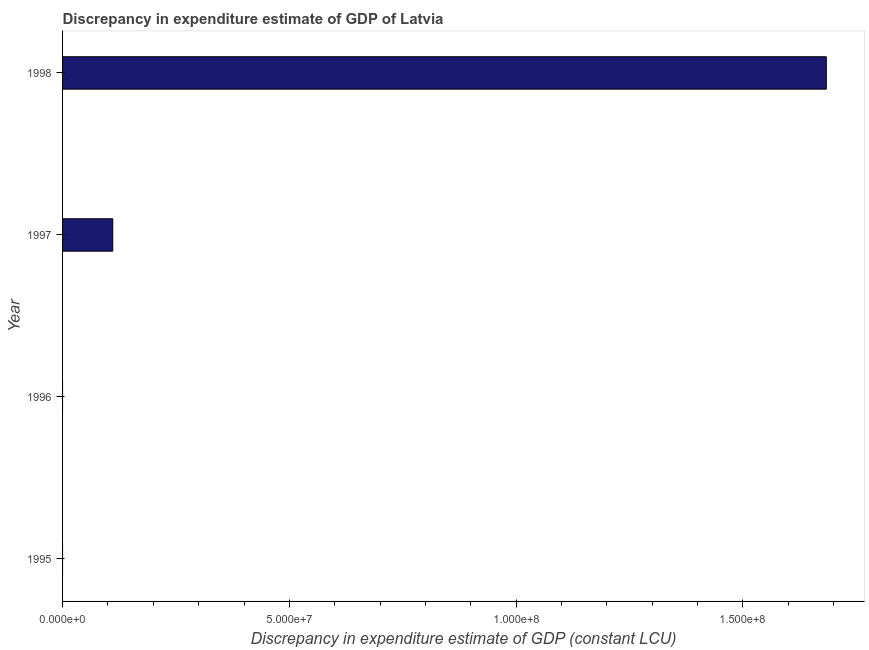Does the graph contain any zero values?
Offer a very short reply. Yes. What is the title of the graph?
Provide a short and direct response. Discrepancy in expenditure estimate of GDP of Latvia. What is the label or title of the X-axis?
Keep it short and to the point. Discrepancy in expenditure estimate of GDP (constant LCU). What is the discrepancy in expenditure estimate of gdp in 1997?
Your response must be concise. 1.11e+07. Across all years, what is the maximum discrepancy in expenditure estimate of gdp?
Give a very brief answer. 1.68e+08. What is the sum of the discrepancy in expenditure estimate of gdp?
Offer a terse response. 1.79e+08. What is the average discrepancy in expenditure estimate of gdp per year?
Keep it short and to the point. 4.49e+07. What is the median discrepancy in expenditure estimate of gdp?
Offer a terse response. 5.53e+06. In how many years, is the discrepancy in expenditure estimate of gdp greater than 80000000 LCU?
Make the answer very short. 1. What is the ratio of the discrepancy in expenditure estimate of gdp in 1997 to that in 1998?
Your response must be concise. 0.07. Is the discrepancy in expenditure estimate of gdp in 1997 less than that in 1998?
Your answer should be compact. Yes. Is the difference between the discrepancy in expenditure estimate of gdp in 1997 and 1998 greater than the difference between any two years?
Offer a very short reply. No. Is the sum of the discrepancy in expenditure estimate of gdp in 1997 and 1998 greater than the maximum discrepancy in expenditure estimate of gdp across all years?
Your response must be concise. Yes. What is the difference between the highest and the lowest discrepancy in expenditure estimate of gdp?
Provide a succinct answer. 1.68e+08. How many years are there in the graph?
Make the answer very short. 4. What is the difference between two consecutive major ticks on the X-axis?
Ensure brevity in your answer.  5.00e+07. Are the values on the major ticks of X-axis written in scientific E-notation?
Give a very brief answer. Yes. What is the Discrepancy in expenditure estimate of GDP (constant LCU) of 1995?
Offer a terse response. 0. What is the Discrepancy in expenditure estimate of GDP (constant LCU) of 1997?
Make the answer very short. 1.11e+07. What is the Discrepancy in expenditure estimate of GDP (constant LCU) in 1998?
Make the answer very short. 1.68e+08. What is the difference between the Discrepancy in expenditure estimate of GDP (constant LCU) in 1997 and 1998?
Your answer should be very brief. -1.57e+08. What is the ratio of the Discrepancy in expenditure estimate of GDP (constant LCU) in 1997 to that in 1998?
Keep it short and to the point. 0.07. 